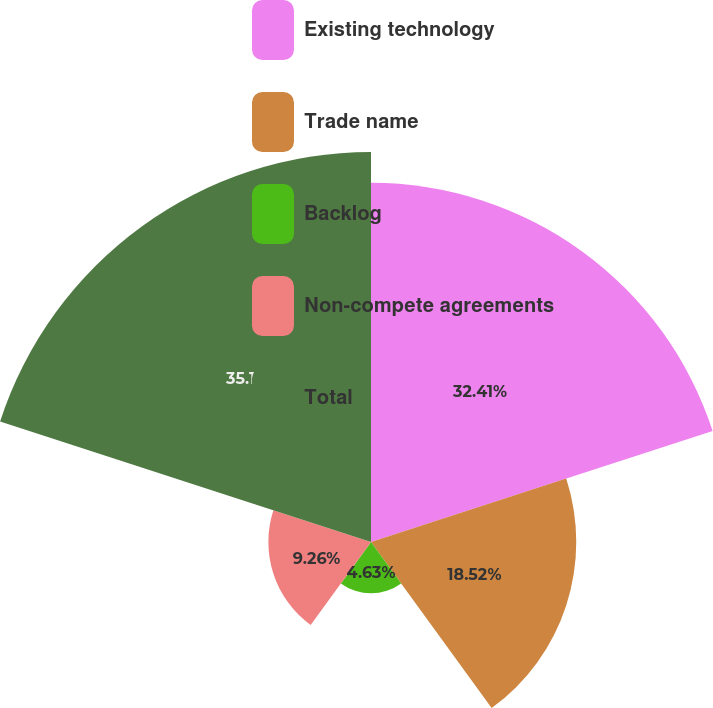Convert chart to OTSL. <chart><loc_0><loc_0><loc_500><loc_500><pie_chart><fcel>Existing technology<fcel>Trade name<fcel>Backlog<fcel>Non-compete agreements<fcel>Total<nl><fcel>32.41%<fcel>18.52%<fcel>4.63%<fcel>9.26%<fcel>35.19%<nl></chart> 